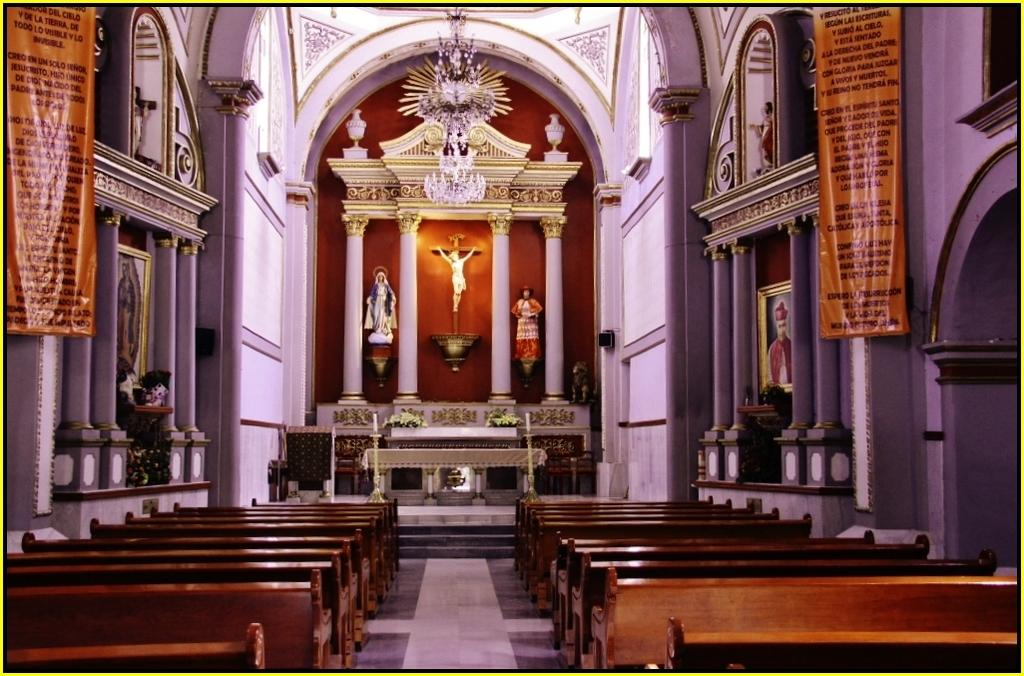What part of a building is shown in the image? The image shows the inner part of a building. What type of furniture is present in the image? There are benches in the image. What type of decorative elements can be seen in the image? There are statues, pillars, banners, and frames attached to the wall in the image. What type of natural elements are present in the image? There are flowers in the image. What type of clover can be seen growing on the floor in the image? There is no clover present in the image; it is an indoor setting with no visible plants. 